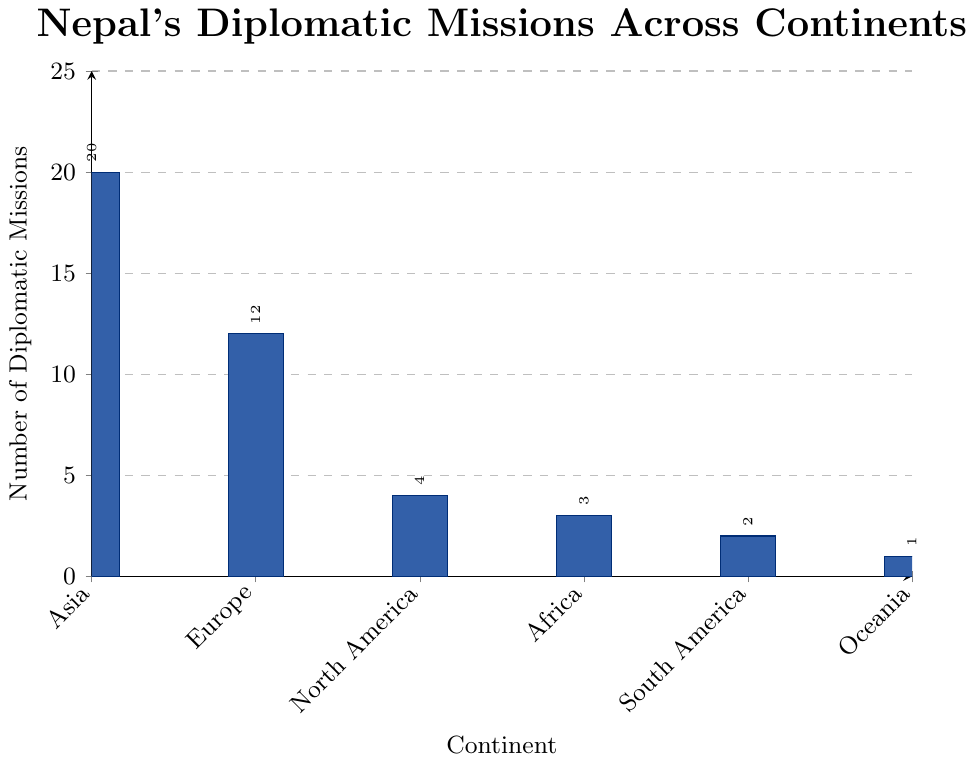Which continent has the highest number of diplomatic missions? By visually inspecting the heights of the bars on the chart, we see that the bar representing Asia is the tallest.
Answer: Asia What is the difference in the number of diplomatic missions between Asia and Europe? Asia has 20 diplomatic missions and Europe has 12 diplomatic missions. Subtracting the number of missions in Europe from that in Asia, we get 20 - 12 = 8.
Answer: 8 How many more diplomatic missions does Nepal have in Asia compared to North America and Oceania combined? North America has 4 missions and Oceania has 1 mission. The combined number of missions in North America and Oceania is 4 + 1 = 5. Asia has 20 missions. The difference is 20 - 5 = 15.
Answer: 15 What is the total number of diplomatic missions in all continents combined? Summing the number of diplomatic missions in all the continents: 20 (Asia) + 12 (Europe) + 4 (North America) + 3 (Africa) + 2 (South America) + 1 (Oceania) = 42.
Answer: 42 Which continents have fewer than 5 diplomatic missions? By visually comparing the heights of the bars, we see that North America (4), Africa (3), South America (2), and Oceania (1) all have fewer than 5 missions.
Answer: North America, Africa, South America, Oceania What is the ratio of diplomatic missions in Europe to those in Oceania? Europe has 12 diplomatic missions, and Oceania has 1 diplomatic mission. The ratio of the number of missions in Europe to those in Oceania is 12:1.
Answer: 12:1 How does the number of diplomatic missions in North America compare to Africa? By comparing the heights of the bars, we see that North America has 4 missions while Africa has 3 missions. North America has 1 more mission than Africa.
Answer: North America has 1 more mission than Africa What percentage of the total diplomatic missions are in Asia? Asia has 20 diplomatic missions. The total number of missions is 42. To find the percentage, we calculate (20 / 42) * 100 ≈ 47.62%.
Answer: Approximately 47.62% If Asia and Europe were combined into a single entity, how many diplomatic missions would it have? Asia has 20 diplomatic missions, and Europe has 12. Combining them would result in 20 + 12 = 32 missions.
Answer: 32 Is the number of diplomatic missions in South America the same as the number in Africa? South America has 2 diplomatic missions, and Africa has 3 missions. Therefore, the number of diplomatic missions is not the same.
Answer: No 